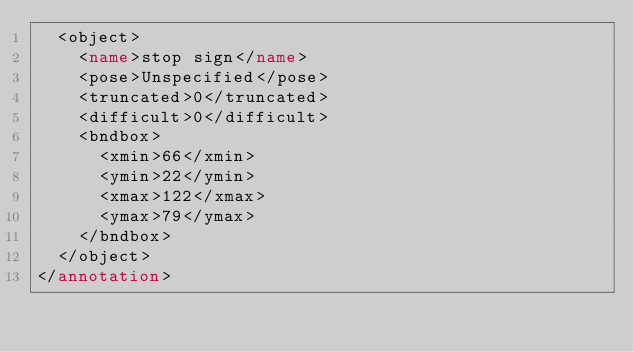Convert code to text. <code><loc_0><loc_0><loc_500><loc_500><_XML_>	<object>
		<name>stop sign</name>
		<pose>Unspecified</pose>
		<truncated>0</truncated>
		<difficult>0</difficult>
		<bndbox>
			<xmin>66</xmin>
			<ymin>22</ymin>
			<xmax>122</xmax>
			<ymax>79</ymax>
		</bndbox>
	</object>
</annotation>
</code> 